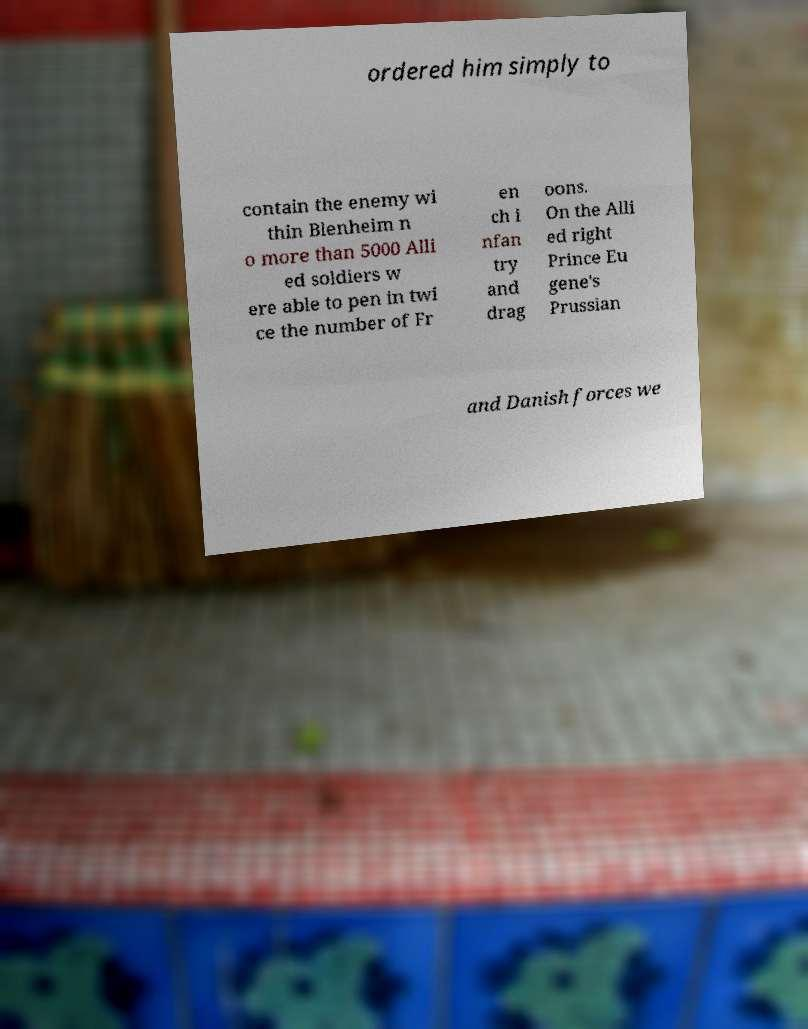Can you read and provide the text displayed in the image?This photo seems to have some interesting text. Can you extract and type it out for me? ordered him simply to contain the enemy wi thin Blenheim n o more than 5000 Alli ed soldiers w ere able to pen in twi ce the number of Fr en ch i nfan try and drag oons. On the Alli ed right Prince Eu gene's Prussian and Danish forces we 